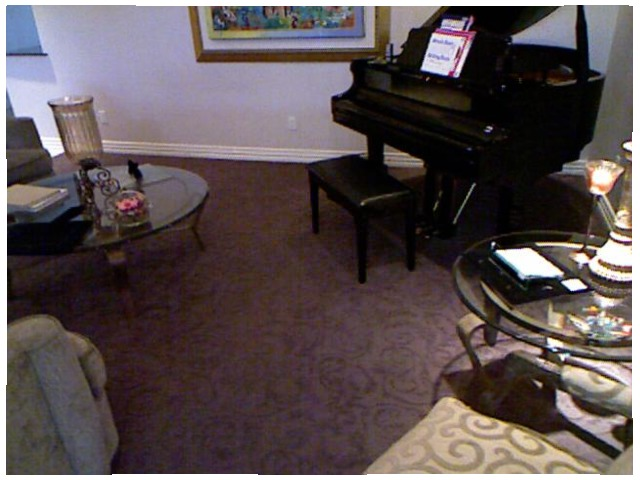<image>
Is there a piano behind the table? No. The piano is not behind the table. From this viewpoint, the piano appears to be positioned elsewhere in the scene. Is there a table to the left of the chair? No. The table is not to the left of the chair. From this viewpoint, they have a different horizontal relationship. 